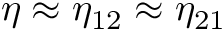Convert formula to latex. <formula><loc_0><loc_0><loc_500><loc_500>\eta \approx \eta _ { 1 2 } \approx \eta _ { 2 1 }</formula> 